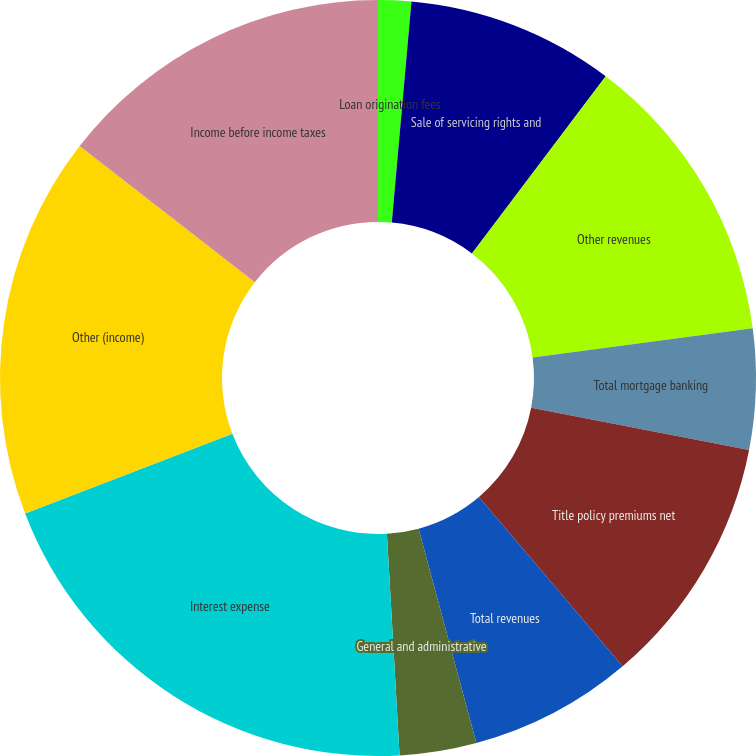Convert chart to OTSL. <chart><loc_0><loc_0><loc_500><loc_500><pie_chart><fcel>Loan origination fees<fcel>Sale of servicing rights and<fcel>Other revenues<fcel>Total mortgage banking<fcel>Title policy premiums net<fcel>Total revenues<fcel>General and administrative<fcel>Interest expense<fcel>Other (income)<fcel>Income before income taxes<nl><fcel>1.41%<fcel>8.88%<fcel>12.61%<fcel>5.15%<fcel>10.75%<fcel>7.01%<fcel>3.28%<fcel>20.08%<fcel>16.35%<fcel>14.48%<nl></chart> 